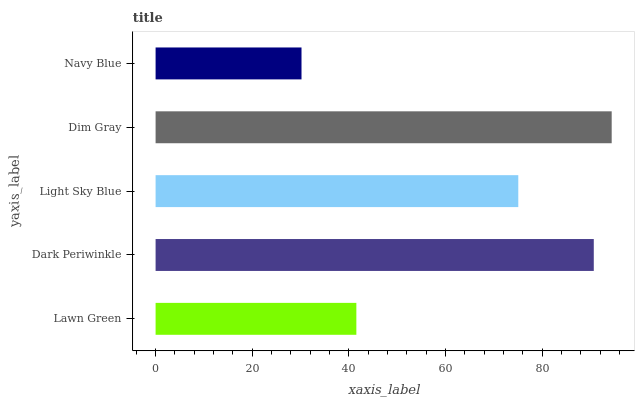Is Navy Blue the minimum?
Answer yes or no. Yes. Is Dim Gray the maximum?
Answer yes or no. Yes. Is Dark Periwinkle the minimum?
Answer yes or no. No. Is Dark Periwinkle the maximum?
Answer yes or no. No. Is Dark Periwinkle greater than Lawn Green?
Answer yes or no. Yes. Is Lawn Green less than Dark Periwinkle?
Answer yes or no. Yes. Is Lawn Green greater than Dark Periwinkle?
Answer yes or no. No. Is Dark Periwinkle less than Lawn Green?
Answer yes or no. No. Is Light Sky Blue the high median?
Answer yes or no. Yes. Is Light Sky Blue the low median?
Answer yes or no. Yes. Is Lawn Green the high median?
Answer yes or no. No. Is Navy Blue the low median?
Answer yes or no. No. 